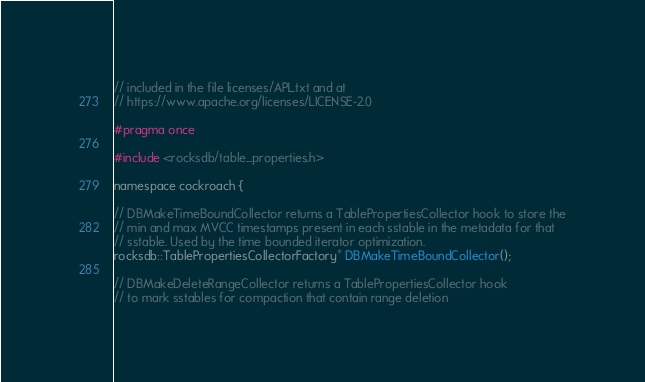Convert code to text. <code><loc_0><loc_0><loc_500><loc_500><_C_>// included in the file licenses/APL.txt and at
// https://www.apache.org/licenses/LICENSE-2.0

#pragma once

#include <rocksdb/table_properties.h>

namespace cockroach {

// DBMakeTimeBoundCollector returns a TablePropertiesCollector hook to store the
// min and max MVCC timestamps present in each sstable in the metadata for that
// sstable. Used by the time bounded iterator optimization.
rocksdb::TablePropertiesCollectorFactory* DBMakeTimeBoundCollector();

// DBMakeDeleteRangeCollector returns a TablePropertiesCollector hook
// to mark sstables for compaction that contain range deletion</code> 